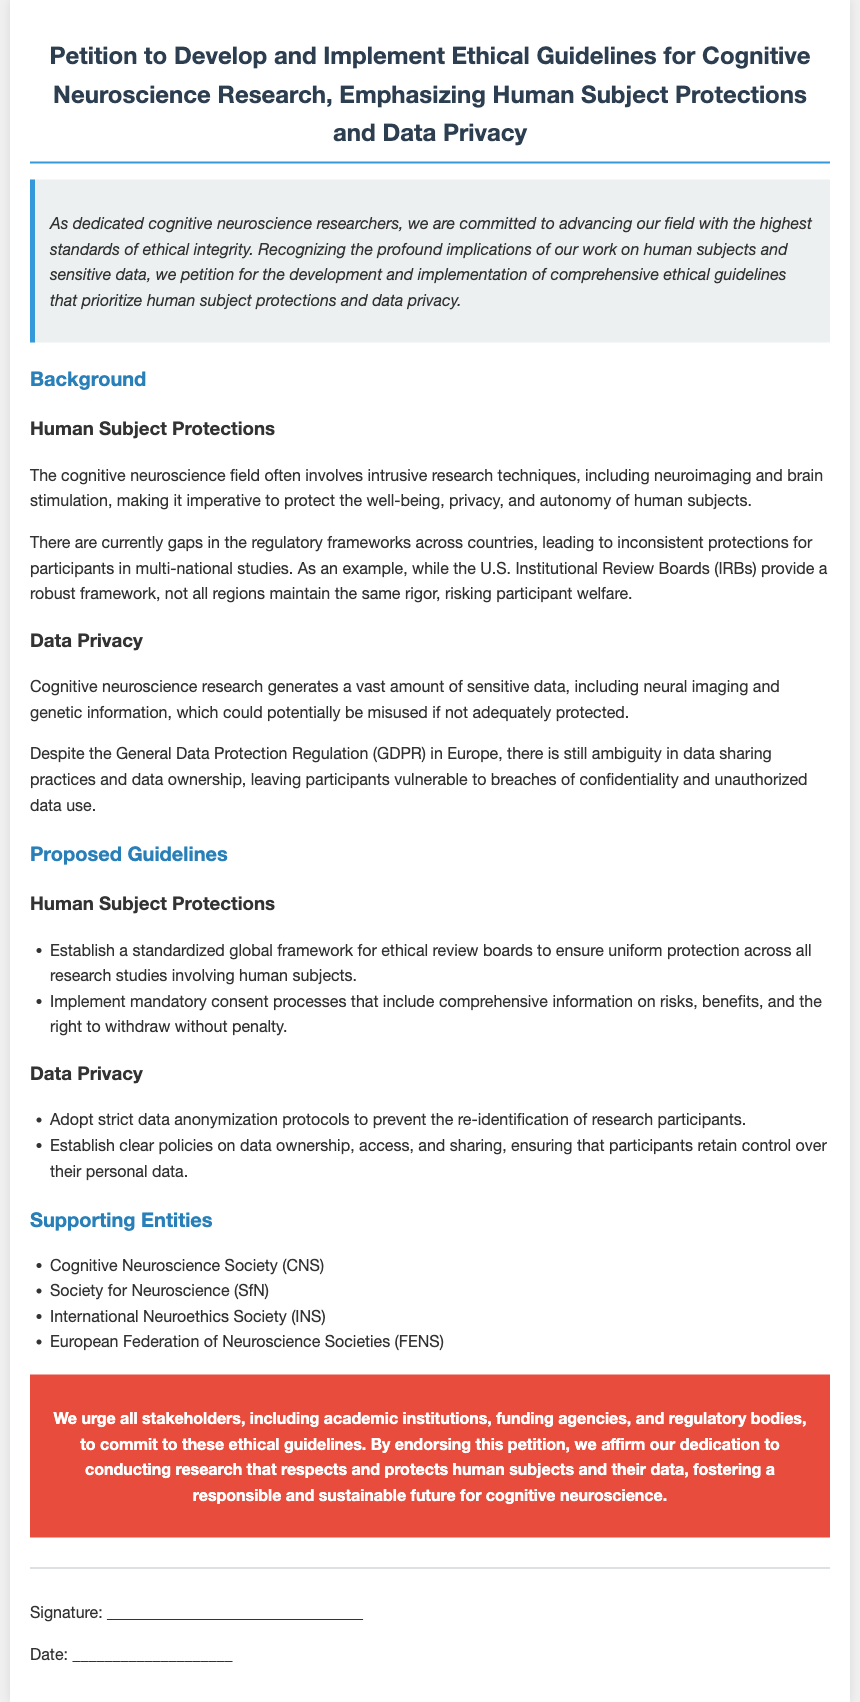what is the title of the petition? The title is located at the top of the document and summarizes the main focus of the petition.
Answer: Petition to Develop and Implement Ethical Guidelines for Cognitive Neuroscience Research, Emphasizing Human Subject Protections and Data Privacy who is a supporting entity mentioned in the document? The supporting entities are listed under a specific section in the document, highlighting organizations involved in cognitive neuroscience.
Answer: Cognitive Neuroscience Society (CNS) what is one proposed guideline for human subject protections? The proposed guidelines are presented in a bullet point format, indicating measures that should be taken for human subjects.
Answer: Establish a standardized global framework for ethical review boards how many areas of concern are discussed in the background section? The background section contains two main concerns which are mentioned in their respective headings.
Answer: Two what is the main call to action in the petition? The call to action summarizes the urgency and the appeal to stakeholders in the field concerning the guidelines.
Answer: We urge all stakeholders to commit to these ethical guidelines 